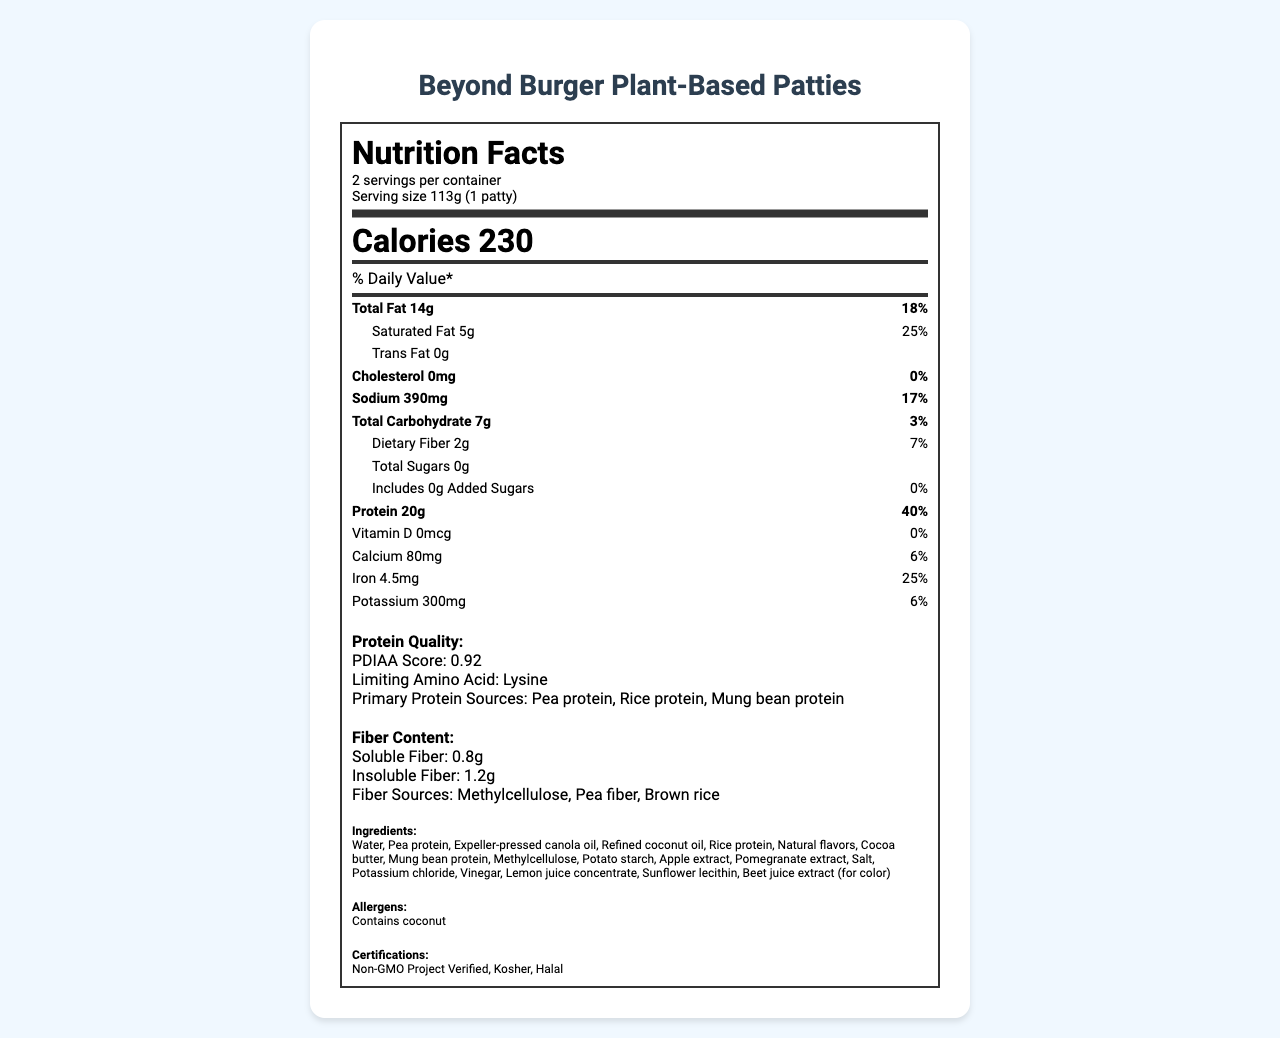what is the serving size of the Beyond Burger Plant-Based Patties? The serving size is clearly stated in the nutrition facts: "Serving size 113g (1 patty)".
Answer: 113g (1 patty) how many calories are in one serving? The document lists "Calories 230" under the nutrients information.
Answer: 230 what is the amount of total fat per serving? The "Total Fat" amount is stated as 14g in the nutrition facts.
Answer: 14g what is the PDIAA score for protein quality? Under the "Protein Quality" section, it says "PDIAA Score: 0.92".
Answer: 0.92 what are the primary protein sources? The primary protein sources are listed under the "Protein Quality" section as "Pea protein, Rice protein, Mung bean protein".
Answer: Pea protein, Rice protein, Mung bean protein how much dietary fiber does one serving contain? The document states "Dietary Fiber 2g" in the nutrient section.
Answer: 2g how much of the daily value of protein does one serving provide? The daily value for protein, listed in the nutrition facts, is 40%.
Answer: 40% Which of the following certifications does the product have? A. USDA Organic B. Non-GMO Project Verified C. Vegan Certified D. Gluten-Free The certifications listed include "Non-GMO Project Verified" but do not mention USDA Organic, Vegan Certified, or Gluten-Free.
Answer: B. Non-GMO Project Verified What are the main sources of fiber in this product? 1. Wheat bran, 2. Psyllium husk, 3. Methylcellulose, 4. Pea fiber, 5. Brown rice The fiber sources listed are "Methylcellulose, Pea fiber, Brown rice".
Answer: 3, 4, 5 Is the Beyond Burger Plant-Based Patties product cholesterol-free? The nutrition facts state "Cholesterol 0mg" which means it is cholesterol-free.
Answer: Yes Summarize the main nutritional and compositional highlights of Beyond Burger Plant-Based Patties. The nutrition facts list all the macronutrients, vitamins, and minerals per serving, highlighting the high protein content (20g) with a high PDIAA score, a significant amount of fiber, and lack of cholesterol. It also lists ingredients and allergens, along with product certifications.
Answer: The Beyond Burger Plant-Based Patties have a serving size of 113g (1 patty) and contain 230 calories per serving. Each serving provides 20g of protein (with a PDIAA score of 0.92) and 2g of dietary fiber. The product is cholesterol-free, with low carbohydrates and sugars. Key ingredients include various plant proteins and fiber sources. The product is also Non-GMO Project Verified, Kosher, and Halal certified. Is the limiting amino acid lysine in the Beyond Burger Plant-Based Patties? The protein quality section mentions that the limiting amino acid in this product is lysine.
Answer: Yes How many servings are there per container? The nutrition facts explicitly state there are "2 servings per container".
Answer: 2 What is the amount of soluble fiber per serving? The fiber content section lists "Soluble Fiber: 0.8g".
Answer: 0.8g How does the PDIAA score of Beyond Burger's protein quality compare to typical animal-based proteins? The data analysis notes state that the PDIAA score of 0.92 indicates high protein quality, comparable to animal-based proteins.
Answer: Comparable What is the purpose of the beet juice extract in the ingredients list? The document does not provide specific information on the purpose of beet juice extract in the ingredients.
Answer: Cannot be determined 